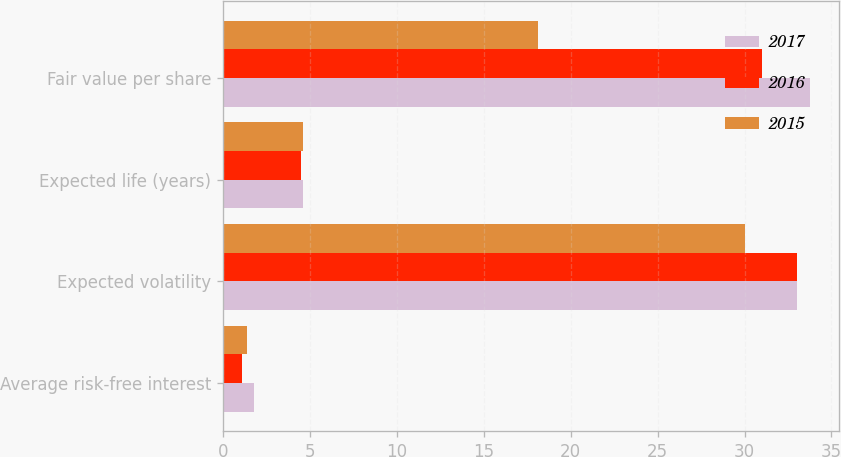<chart> <loc_0><loc_0><loc_500><loc_500><stacked_bar_chart><ecel><fcel>Average risk-free interest<fcel>Expected volatility<fcel>Expected life (years)<fcel>Fair value per share<nl><fcel>2017<fcel>1.8<fcel>33<fcel>4.6<fcel>33.74<nl><fcel>2016<fcel>1.1<fcel>33<fcel>4.5<fcel>31<nl><fcel>2015<fcel>1.4<fcel>30<fcel>4.6<fcel>18.13<nl></chart> 